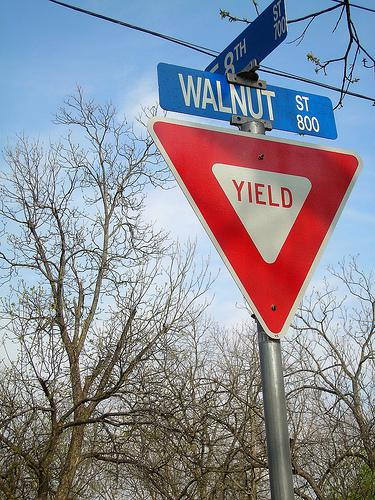Question: what color are the street signs?
Choices:
A. Brown.
B. Yellow and red.
C. Green.
D. Blue and white.
Answer with the letter. Answer: D Question: what color are the trees?
Choices:
A. Yellow.
B. Black.
C. Red.
D. Brown and green.
Answer with the letter. Answer: D Question: where is the yield sign?
Choices:
A. On the street.
B. In the median.
C. In the roundabout.
D. On a pole.
Answer with the letter. Answer: D Question: what is the pole made of?
Choices:
A. Wood.
B. Metal.
C. Plastic.
D. Aluminum.
Answer with the letter. Answer: B Question: how many yield signs are there?
Choices:
A. One.
B. Two.
C. Five.
D. Three.
Answer with the letter. Answer: A Question: what color is the pole?
Choices:
A. White.
B. Black.
C. Purple.
D. Gray.
Answer with the letter. Answer: D 